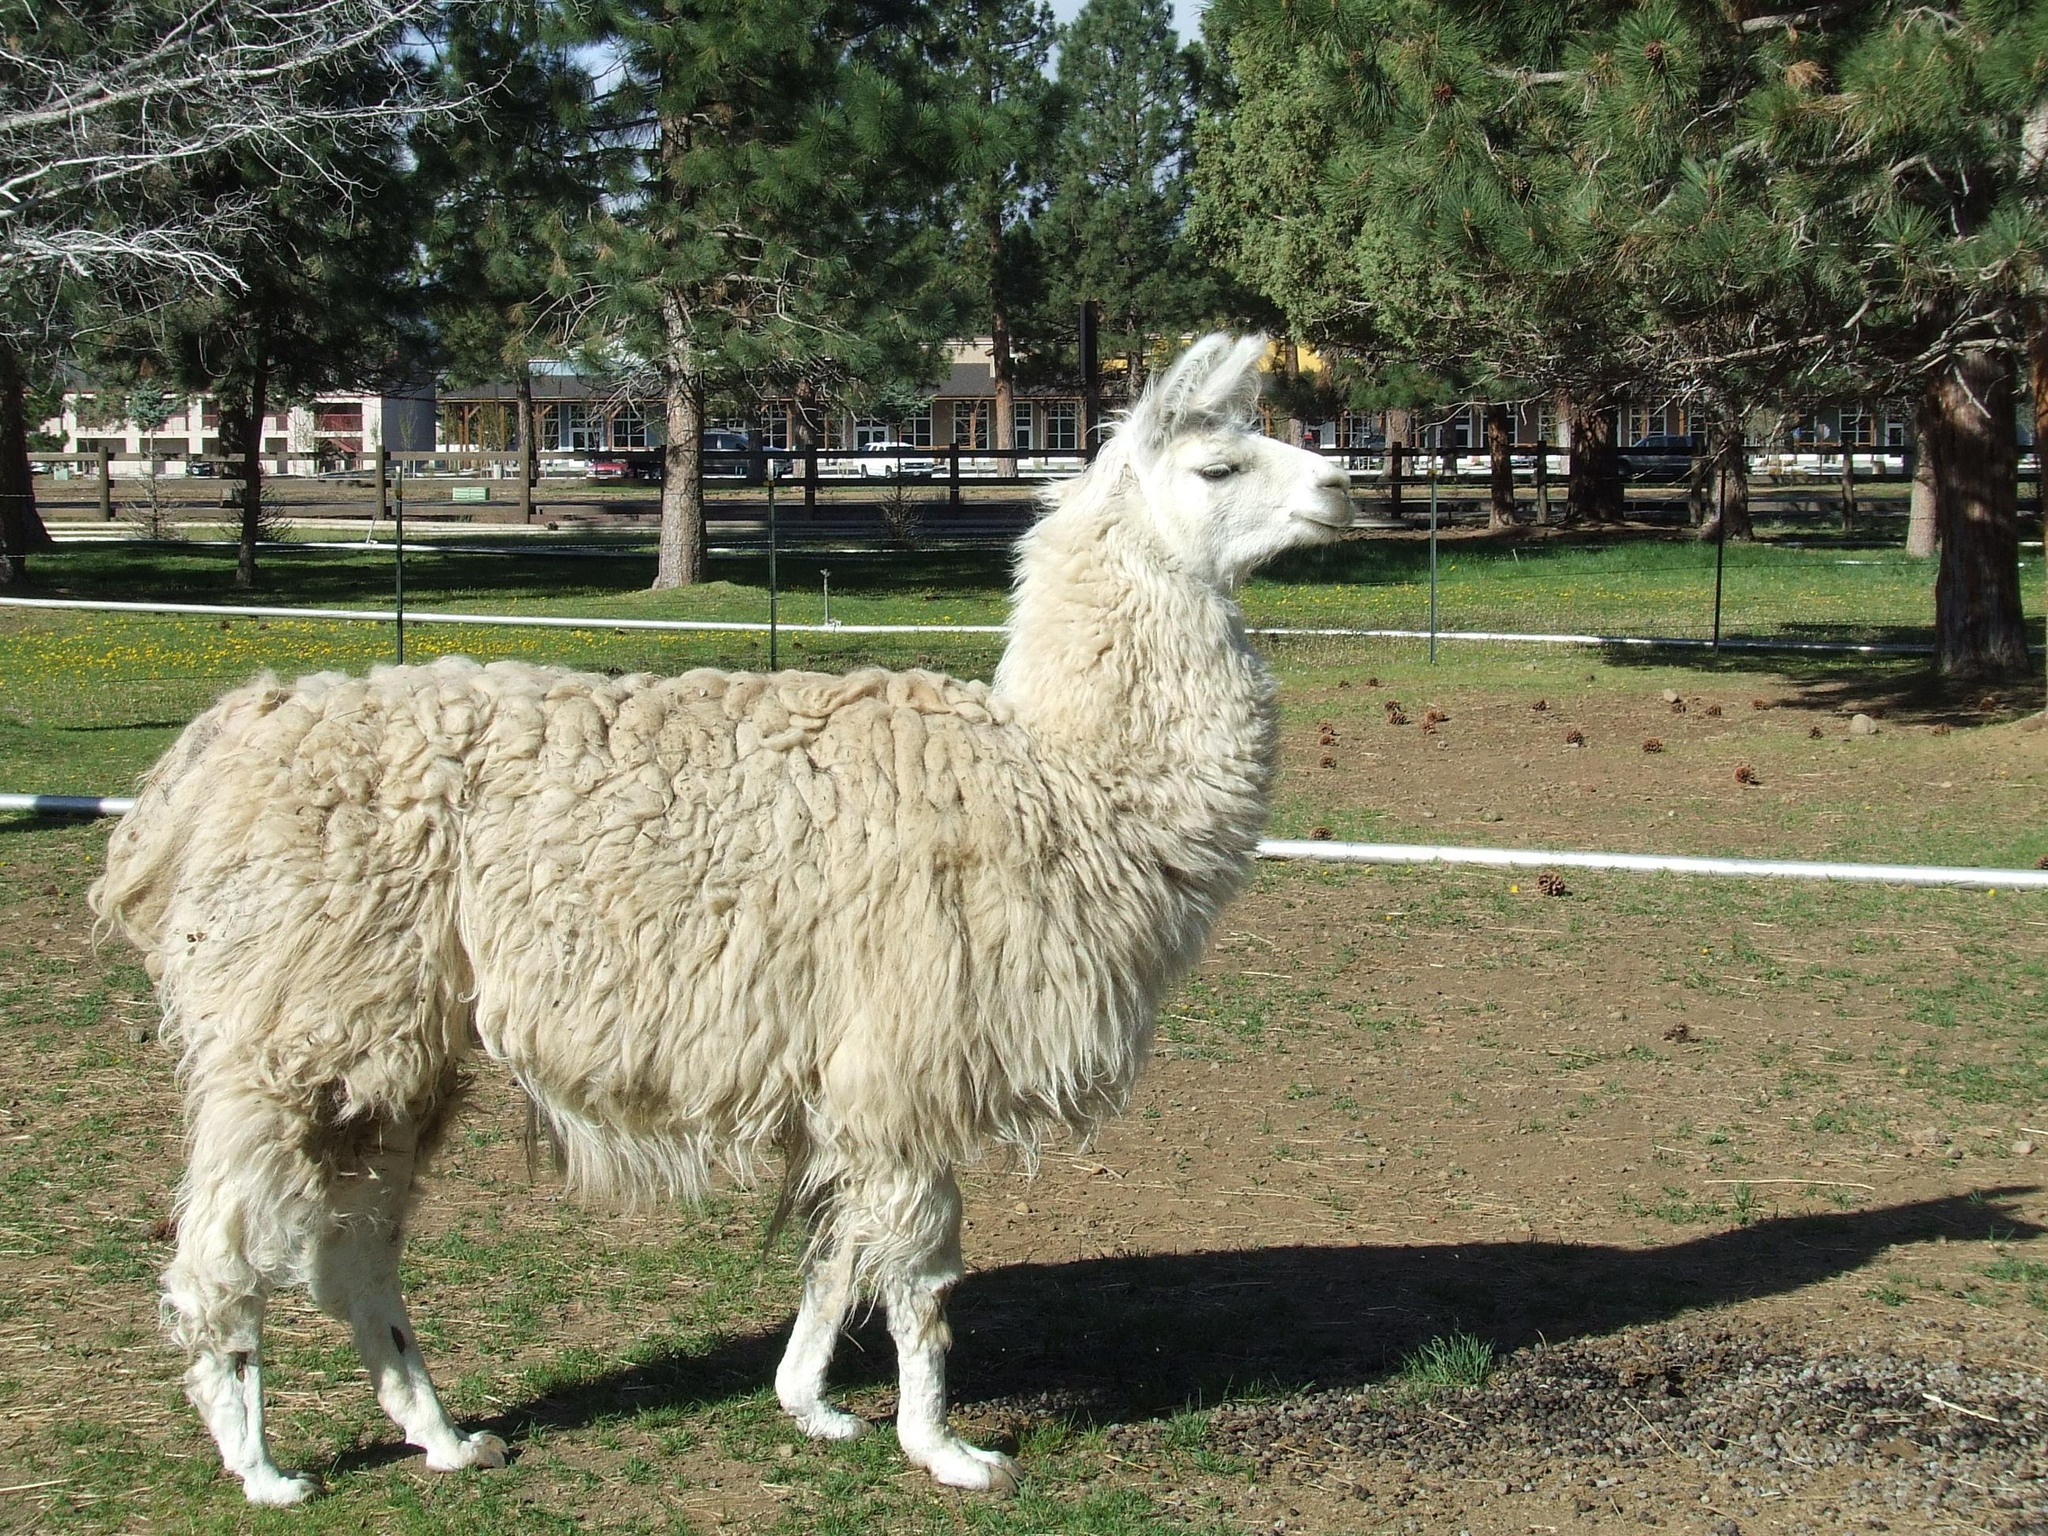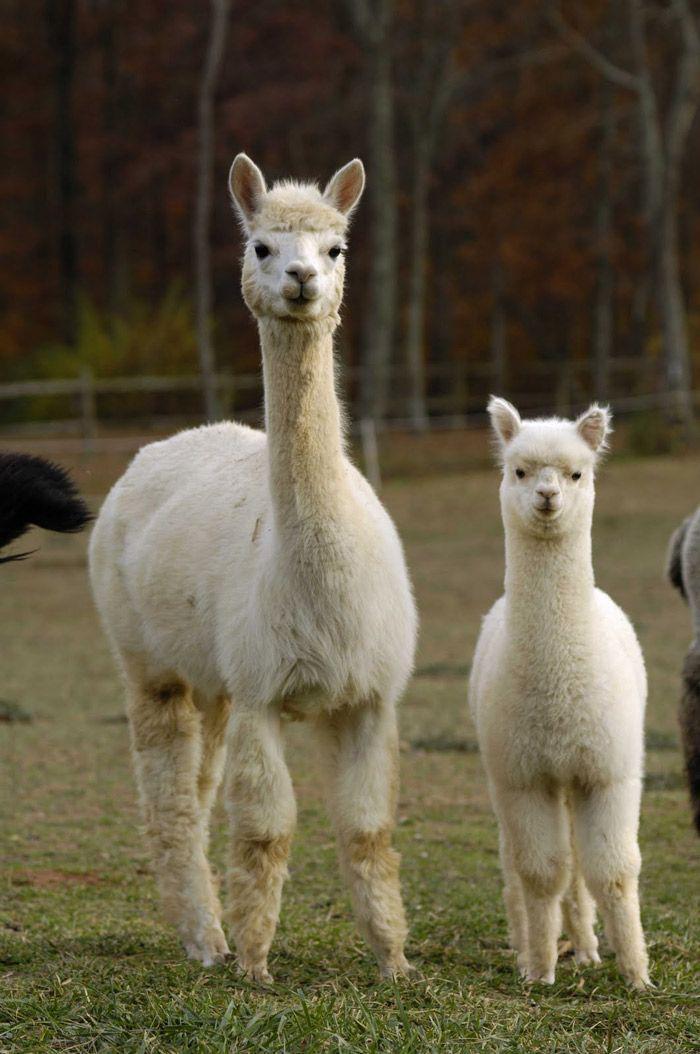The first image is the image on the left, the second image is the image on the right. Analyze the images presented: Is the assertion "In one image, two llamas - including a brown-and-white one - are next to a rustic stone wall." valid? Answer yes or no. No. The first image is the image on the left, the second image is the image on the right. For the images shown, is this caption "One llama is not standing on four legs." true? Answer yes or no. No. 